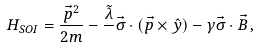<formula> <loc_0><loc_0><loc_500><loc_500>H _ { S O I } = \frac { \vec { p } ^ { 2 } } { 2 m } - \frac { \tilde { \lambda } } { } \vec { \sigma } \cdot ( \vec { p } \times \hat { y } ) - \gamma \vec { \sigma } \cdot \vec { B } \, ,</formula> 